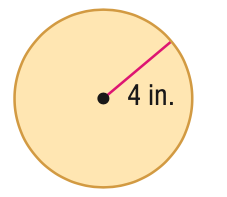Answer the mathemtical geometry problem and directly provide the correct option letter.
Question: Find the perimeter or circumference of the figure. Round to the nearest tenth.
Choices: A: 12.6 B: 24 C: 25.1 D: 50.2 C 